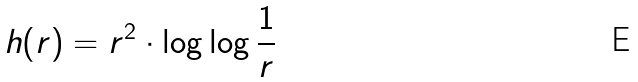Convert formula to latex. <formula><loc_0><loc_0><loc_500><loc_500>h ( r ) = r ^ { 2 } \cdot \log \log \frac { 1 } { r }</formula> 